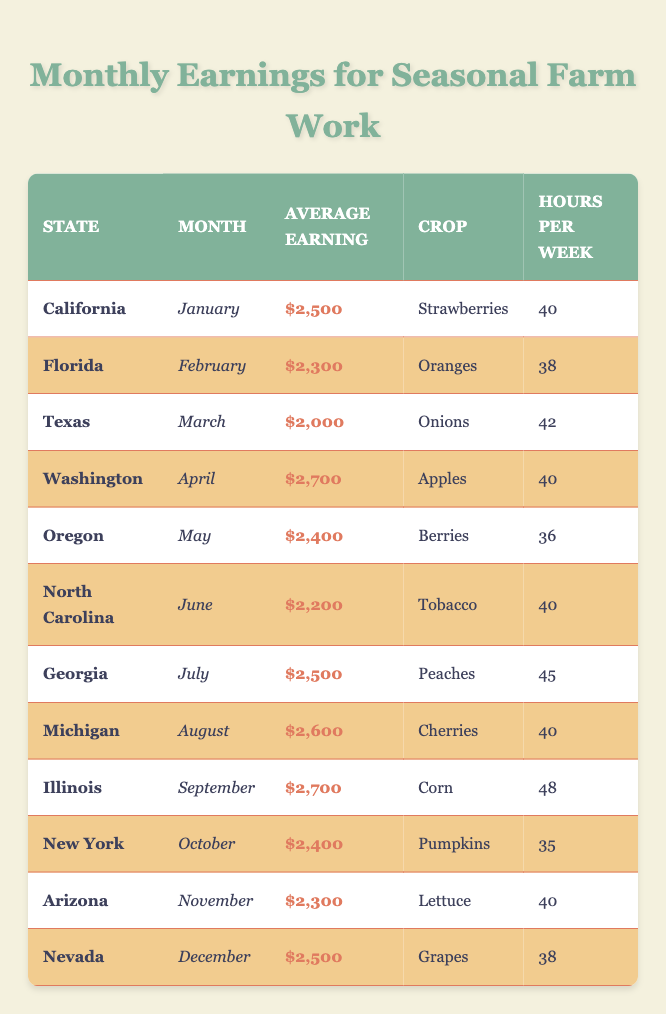What is the average earning for farm work in California during January? The table shows that the average earning in California for January is listed as $2,500.
Answer: $2,500 Which crop is associated with the highest average earning in April? The table indicates that Washington has the highest average earning for April at $2,700, with the crop being Apples.
Answer: Apples How many hours do farmworkers work per week in Georgia during July? According to the table, farmworkers in Georgia in July work 45 hours per week.
Answer: 45 What is the difference in average earnings between Illinois in September and Texas in March? Illinois has an average earning of $2,700 in September, and Texas has an average earning of $2,000 in March. The difference is $2,700 - $2,000 = $700.
Answer: $700 Is the average earning for seasonal farm work in Florida lower than in North Carolina? Florida's average earning is $2,300 in February, while North Carolina's is $2,200 in June. Since $2,300 is greater than $2,200, the answer is no.
Answer: No What is the total average earning for all states combined in June and October? The average earning in June (North Carolina) is $2,200 and in October (New York) is $2,400. Adding these together gives $2,200 + $2,400 = $4,600.
Answer: $4,600 What is the month when farmworkers earn the least on average? By checking the earnings from March at $2,000, which is the lowest in the table, we see that the month is March.
Answer: March Which state has the lowest hours worked per week based on the table and what is that number? The state with the lowest hours worked is Oregon with 36 hours per week in May.
Answer: 36 What are the average earnings in November for Arizona and how does it compare to North Carolina's earning in June? Arizona earns $2,300 in November, while North Carolina earns $2,200 in June. $2,300 is greater, so Arizona has a higher earning.
Answer: Arizona is higher Calculate the average earning across all months for the crops listed in the table. The total average earnings in the months from the table adds up to $2,500 + $2,300 + $2,000 + $2,700 + $2,400 + $2,200 + $2,500 + $2,600 + $2,700 + $2,400 + $2,300 + $2,500 = $29,800. There are 12 entries, so the average is $29,800 / 12 = $2,483.33
Answer: $2,483.33 